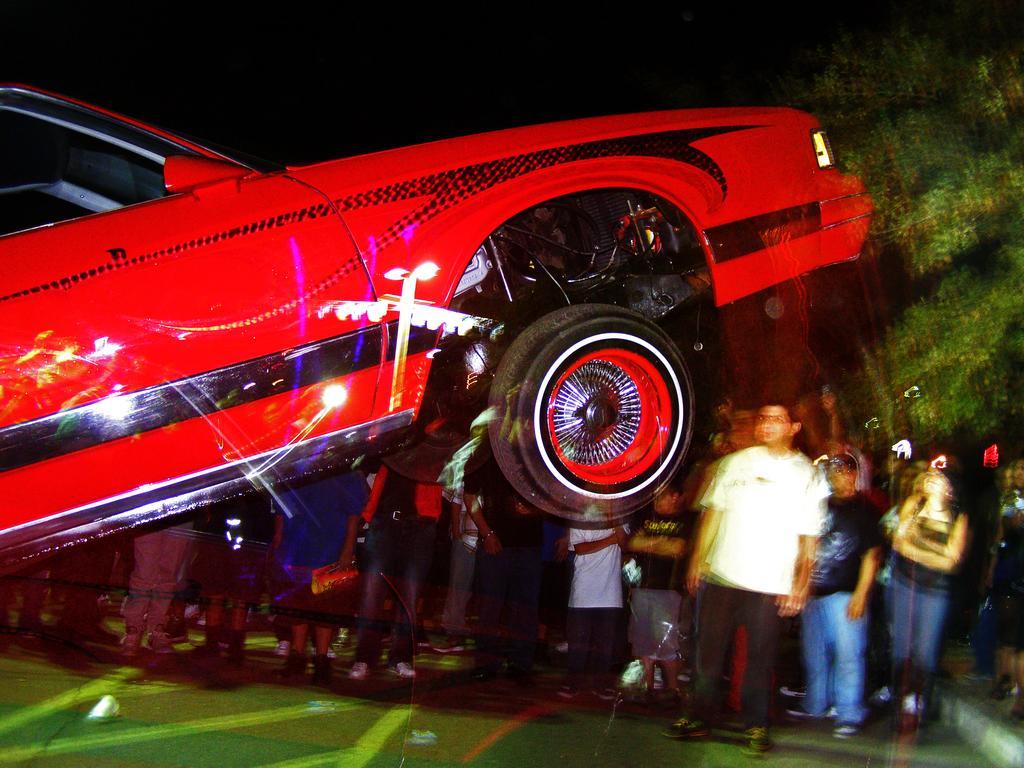In one or two sentences, can you explain what this image depicts? In the foreground of this picture, there is a red colored car and half of the body is in air. In the background, there is a crowd and trees. 